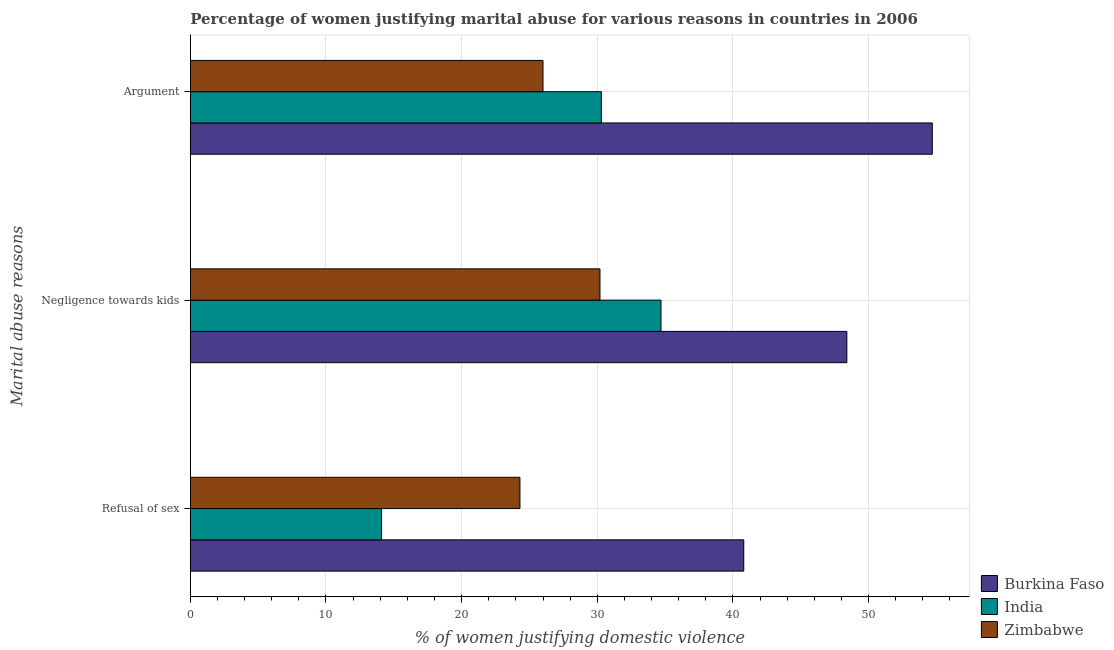How many different coloured bars are there?
Your answer should be very brief. 3. How many bars are there on the 2nd tick from the top?
Your answer should be very brief. 3. What is the label of the 1st group of bars from the top?
Offer a terse response. Argument. What is the percentage of women justifying domestic violence due to arguments in India?
Keep it short and to the point. 30.3. Across all countries, what is the maximum percentage of women justifying domestic violence due to refusal of sex?
Provide a succinct answer. 40.8. Across all countries, what is the minimum percentage of women justifying domestic violence due to negligence towards kids?
Your answer should be very brief. 30.2. In which country was the percentage of women justifying domestic violence due to negligence towards kids maximum?
Your answer should be very brief. Burkina Faso. In which country was the percentage of women justifying domestic violence due to refusal of sex minimum?
Your response must be concise. India. What is the total percentage of women justifying domestic violence due to refusal of sex in the graph?
Give a very brief answer. 79.2. What is the difference between the percentage of women justifying domestic violence due to negligence towards kids in India and that in Burkina Faso?
Ensure brevity in your answer.  -13.7. What is the difference between the percentage of women justifying domestic violence due to negligence towards kids in Zimbabwe and the percentage of women justifying domestic violence due to arguments in India?
Your response must be concise. -0.1. What is the average percentage of women justifying domestic violence due to arguments per country?
Keep it short and to the point. 37. What is the difference between the percentage of women justifying domestic violence due to refusal of sex and percentage of women justifying domestic violence due to negligence towards kids in Zimbabwe?
Your answer should be compact. -5.9. What is the ratio of the percentage of women justifying domestic violence due to arguments in Zimbabwe to that in India?
Make the answer very short. 0.86. Is the percentage of women justifying domestic violence due to refusal of sex in Burkina Faso less than that in India?
Provide a short and direct response. No. Is the difference between the percentage of women justifying domestic violence due to refusal of sex in Burkina Faso and Zimbabwe greater than the difference between the percentage of women justifying domestic violence due to negligence towards kids in Burkina Faso and Zimbabwe?
Offer a very short reply. No. What is the difference between the highest and the second highest percentage of women justifying domestic violence due to refusal of sex?
Your response must be concise. 16.5. What is the difference between the highest and the lowest percentage of women justifying domestic violence due to arguments?
Your response must be concise. 28.7. Is the sum of the percentage of women justifying domestic violence due to negligence towards kids in India and Burkina Faso greater than the maximum percentage of women justifying domestic violence due to arguments across all countries?
Your answer should be compact. Yes. What does the 1st bar from the bottom in Refusal of sex represents?
Your response must be concise. Burkina Faso. Is it the case that in every country, the sum of the percentage of women justifying domestic violence due to refusal of sex and percentage of women justifying domestic violence due to negligence towards kids is greater than the percentage of women justifying domestic violence due to arguments?
Ensure brevity in your answer.  Yes. Are the values on the major ticks of X-axis written in scientific E-notation?
Your answer should be compact. No. Does the graph contain any zero values?
Give a very brief answer. No. Where does the legend appear in the graph?
Offer a terse response. Bottom right. How many legend labels are there?
Your answer should be compact. 3. How are the legend labels stacked?
Offer a terse response. Vertical. What is the title of the graph?
Offer a very short reply. Percentage of women justifying marital abuse for various reasons in countries in 2006. Does "Indonesia" appear as one of the legend labels in the graph?
Your answer should be very brief. No. What is the label or title of the X-axis?
Your answer should be compact. % of women justifying domestic violence. What is the label or title of the Y-axis?
Give a very brief answer. Marital abuse reasons. What is the % of women justifying domestic violence in Burkina Faso in Refusal of sex?
Keep it short and to the point. 40.8. What is the % of women justifying domestic violence in India in Refusal of sex?
Your answer should be compact. 14.1. What is the % of women justifying domestic violence in Zimbabwe in Refusal of sex?
Your answer should be compact. 24.3. What is the % of women justifying domestic violence of Burkina Faso in Negligence towards kids?
Give a very brief answer. 48.4. What is the % of women justifying domestic violence of India in Negligence towards kids?
Provide a succinct answer. 34.7. What is the % of women justifying domestic violence of Zimbabwe in Negligence towards kids?
Your answer should be very brief. 30.2. What is the % of women justifying domestic violence of Burkina Faso in Argument?
Make the answer very short. 54.7. What is the % of women justifying domestic violence of India in Argument?
Offer a terse response. 30.3. What is the % of women justifying domestic violence in Zimbabwe in Argument?
Make the answer very short. 26. Across all Marital abuse reasons, what is the maximum % of women justifying domestic violence of Burkina Faso?
Provide a short and direct response. 54.7. Across all Marital abuse reasons, what is the maximum % of women justifying domestic violence in India?
Offer a very short reply. 34.7. Across all Marital abuse reasons, what is the maximum % of women justifying domestic violence in Zimbabwe?
Your answer should be compact. 30.2. Across all Marital abuse reasons, what is the minimum % of women justifying domestic violence of Burkina Faso?
Provide a succinct answer. 40.8. Across all Marital abuse reasons, what is the minimum % of women justifying domestic violence of Zimbabwe?
Your answer should be compact. 24.3. What is the total % of women justifying domestic violence in Burkina Faso in the graph?
Offer a very short reply. 143.9. What is the total % of women justifying domestic violence of India in the graph?
Offer a very short reply. 79.1. What is the total % of women justifying domestic violence of Zimbabwe in the graph?
Your answer should be compact. 80.5. What is the difference between the % of women justifying domestic violence in Burkina Faso in Refusal of sex and that in Negligence towards kids?
Your answer should be very brief. -7.6. What is the difference between the % of women justifying domestic violence in India in Refusal of sex and that in Negligence towards kids?
Offer a terse response. -20.6. What is the difference between the % of women justifying domestic violence in Zimbabwe in Refusal of sex and that in Negligence towards kids?
Your answer should be very brief. -5.9. What is the difference between the % of women justifying domestic violence of Burkina Faso in Refusal of sex and that in Argument?
Your response must be concise. -13.9. What is the difference between the % of women justifying domestic violence of India in Refusal of sex and that in Argument?
Your response must be concise. -16.2. What is the difference between the % of women justifying domestic violence in Zimbabwe in Negligence towards kids and that in Argument?
Your answer should be very brief. 4.2. What is the difference between the % of women justifying domestic violence of Burkina Faso in Refusal of sex and the % of women justifying domestic violence of India in Negligence towards kids?
Provide a succinct answer. 6.1. What is the difference between the % of women justifying domestic violence of Burkina Faso in Refusal of sex and the % of women justifying domestic violence of Zimbabwe in Negligence towards kids?
Your response must be concise. 10.6. What is the difference between the % of women justifying domestic violence in India in Refusal of sex and the % of women justifying domestic violence in Zimbabwe in Negligence towards kids?
Your answer should be very brief. -16.1. What is the difference between the % of women justifying domestic violence of India in Refusal of sex and the % of women justifying domestic violence of Zimbabwe in Argument?
Make the answer very short. -11.9. What is the difference between the % of women justifying domestic violence of Burkina Faso in Negligence towards kids and the % of women justifying domestic violence of Zimbabwe in Argument?
Offer a terse response. 22.4. What is the difference between the % of women justifying domestic violence in India in Negligence towards kids and the % of women justifying domestic violence in Zimbabwe in Argument?
Your answer should be very brief. 8.7. What is the average % of women justifying domestic violence of Burkina Faso per Marital abuse reasons?
Your answer should be very brief. 47.97. What is the average % of women justifying domestic violence of India per Marital abuse reasons?
Provide a short and direct response. 26.37. What is the average % of women justifying domestic violence of Zimbabwe per Marital abuse reasons?
Make the answer very short. 26.83. What is the difference between the % of women justifying domestic violence of Burkina Faso and % of women justifying domestic violence of India in Refusal of sex?
Offer a terse response. 26.7. What is the difference between the % of women justifying domestic violence of Burkina Faso and % of women justifying domestic violence of Zimbabwe in Refusal of sex?
Keep it short and to the point. 16.5. What is the difference between the % of women justifying domestic violence in India and % of women justifying domestic violence in Zimbabwe in Refusal of sex?
Your answer should be compact. -10.2. What is the difference between the % of women justifying domestic violence in Burkina Faso and % of women justifying domestic violence in Zimbabwe in Negligence towards kids?
Provide a short and direct response. 18.2. What is the difference between the % of women justifying domestic violence in India and % of women justifying domestic violence in Zimbabwe in Negligence towards kids?
Your response must be concise. 4.5. What is the difference between the % of women justifying domestic violence of Burkina Faso and % of women justifying domestic violence of India in Argument?
Your answer should be very brief. 24.4. What is the difference between the % of women justifying domestic violence of Burkina Faso and % of women justifying domestic violence of Zimbabwe in Argument?
Your answer should be compact. 28.7. What is the ratio of the % of women justifying domestic violence in Burkina Faso in Refusal of sex to that in Negligence towards kids?
Keep it short and to the point. 0.84. What is the ratio of the % of women justifying domestic violence of India in Refusal of sex to that in Negligence towards kids?
Offer a terse response. 0.41. What is the ratio of the % of women justifying domestic violence in Zimbabwe in Refusal of sex to that in Negligence towards kids?
Your response must be concise. 0.8. What is the ratio of the % of women justifying domestic violence in Burkina Faso in Refusal of sex to that in Argument?
Ensure brevity in your answer.  0.75. What is the ratio of the % of women justifying domestic violence in India in Refusal of sex to that in Argument?
Ensure brevity in your answer.  0.47. What is the ratio of the % of women justifying domestic violence in Zimbabwe in Refusal of sex to that in Argument?
Offer a terse response. 0.93. What is the ratio of the % of women justifying domestic violence of Burkina Faso in Negligence towards kids to that in Argument?
Offer a very short reply. 0.88. What is the ratio of the % of women justifying domestic violence of India in Negligence towards kids to that in Argument?
Ensure brevity in your answer.  1.15. What is the ratio of the % of women justifying domestic violence of Zimbabwe in Negligence towards kids to that in Argument?
Give a very brief answer. 1.16. What is the difference between the highest and the second highest % of women justifying domestic violence in Zimbabwe?
Give a very brief answer. 4.2. What is the difference between the highest and the lowest % of women justifying domestic violence of India?
Your answer should be very brief. 20.6. 